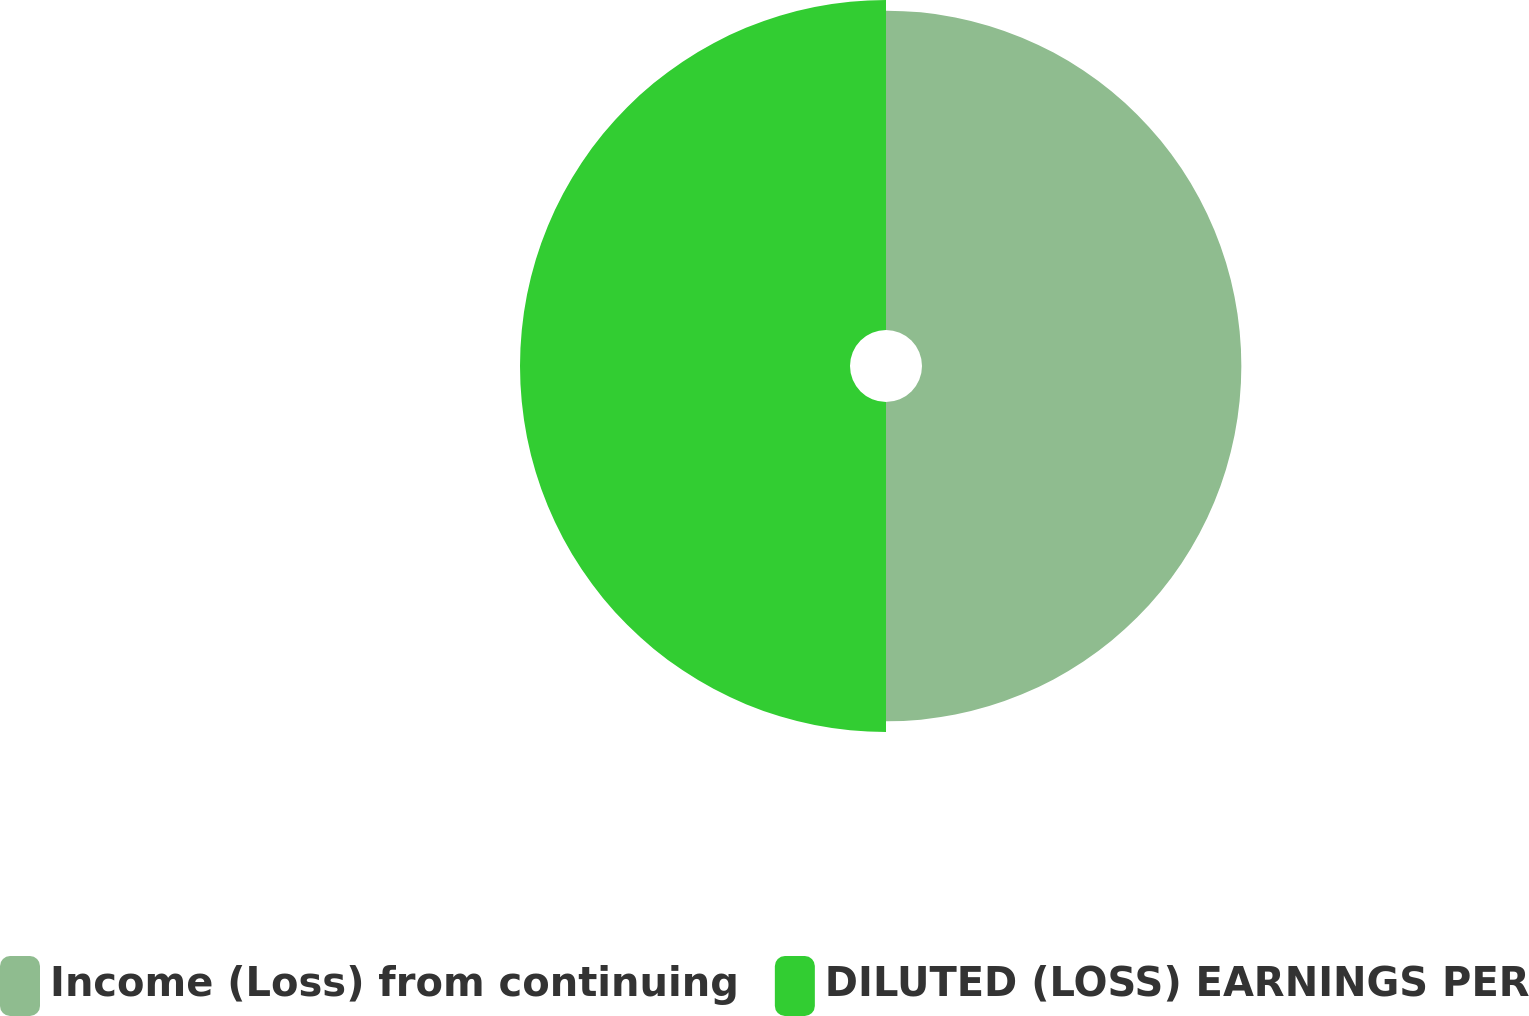Convert chart to OTSL. <chart><loc_0><loc_0><loc_500><loc_500><pie_chart><fcel>Income (Loss) from continuing<fcel>DILUTED (LOSS) EARNINGS PER<nl><fcel>49.18%<fcel>50.82%<nl></chart> 